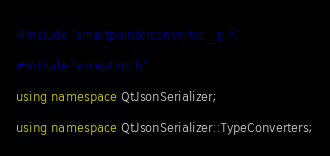<code> <loc_0><loc_0><loc_500><loc_500><_C++_>#include "smartpointerconverter_p.h"
#include "exception.h"
using namespace QtJsonSerializer;
using namespace QtJsonSerializer::TypeConverters;
</code> 